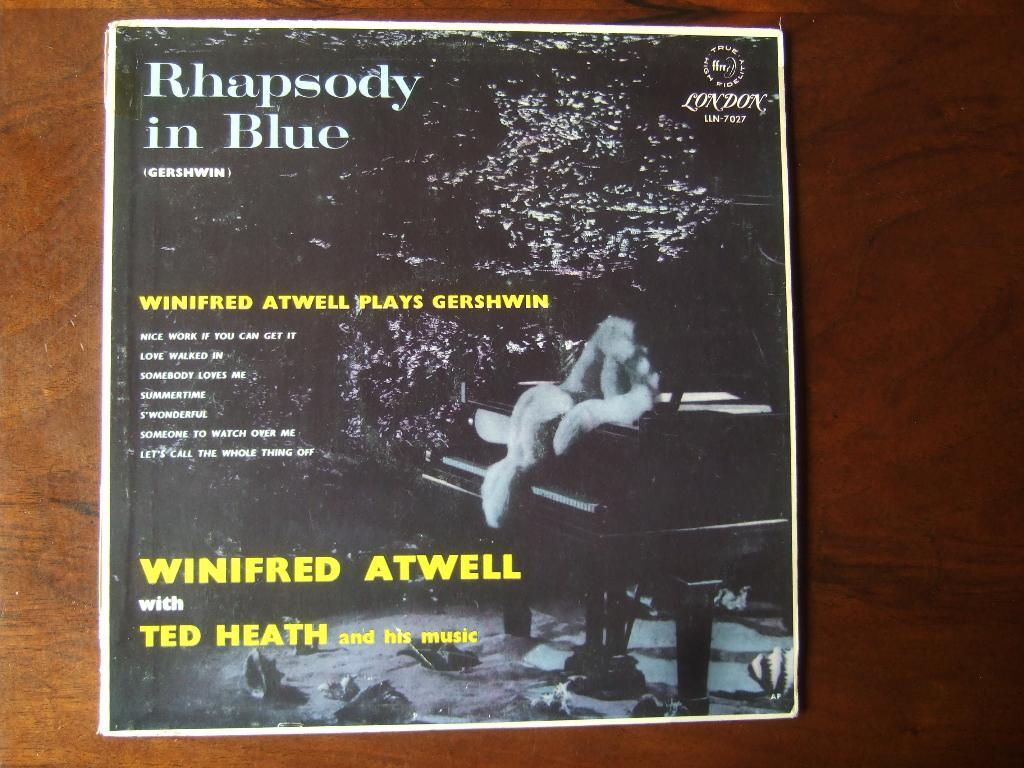Provide a one-sentence caption for the provided image. The album being show is titled Rhapsody in Blue and features Winifred Atwell with Ted Heath and his music. 